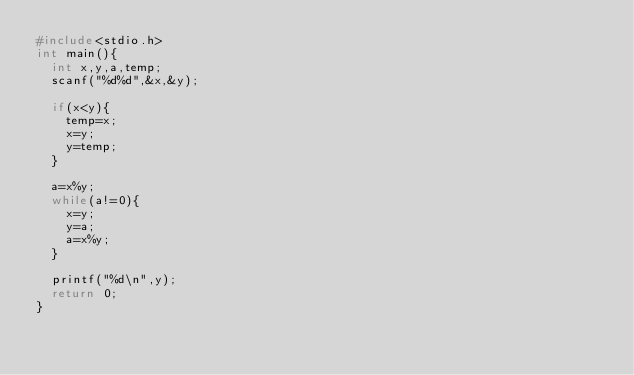Convert code to text. <code><loc_0><loc_0><loc_500><loc_500><_C_>#include<stdio.h>
int main(){
	int x,y,a,temp;
	scanf("%d%d",&x,&y);
	
	if(x<y){
		temp=x;
		x=y;
		y=temp;
	}
	
	a=x%y;
	while(a!=0){
		x=y;
		y=a;
		a=x%y;
	}
	
	printf("%d\n",y);
	return 0;
}
</code> 